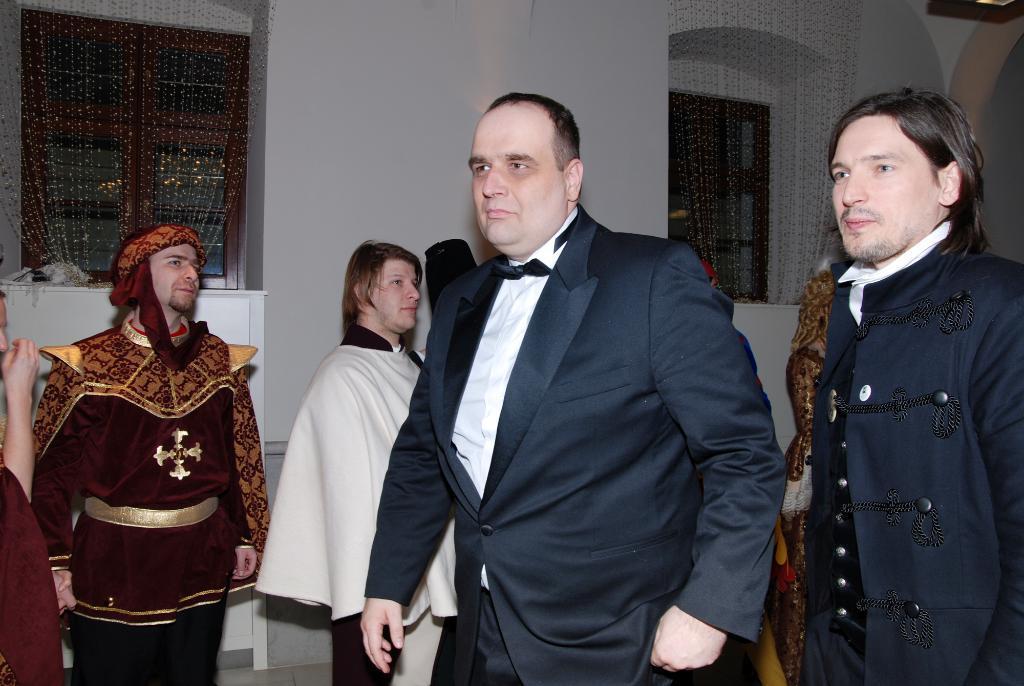Describe this image in one or two sentences. In this picture we can see some people are standing, a man in the front is wearing a suit, in the background there is a wall and two windows. 